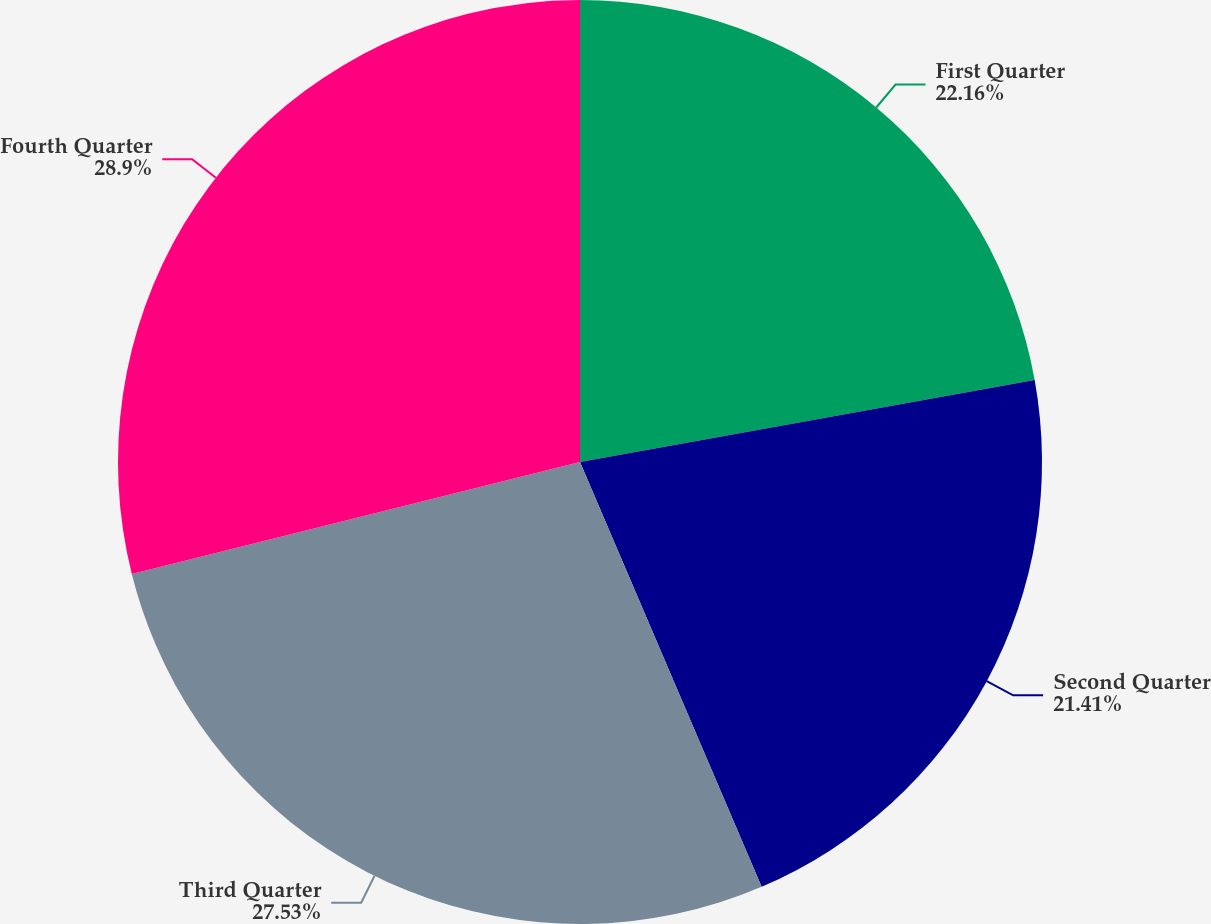<chart> <loc_0><loc_0><loc_500><loc_500><pie_chart><fcel>First Quarter<fcel>Second Quarter<fcel>Third Quarter<fcel>Fourth Quarter<nl><fcel>22.16%<fcel>21.41%<fcel>27.53%<fcel>28.9%<nl></chart> 